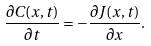Convert formula to latex. <formula><loc_0><loc_0><loc_500><loc_500>\frac { \partial C ( x , t ) } { \partial t } = - \frac { \partial J ( x , t ) } { \partial x } .</formula> 